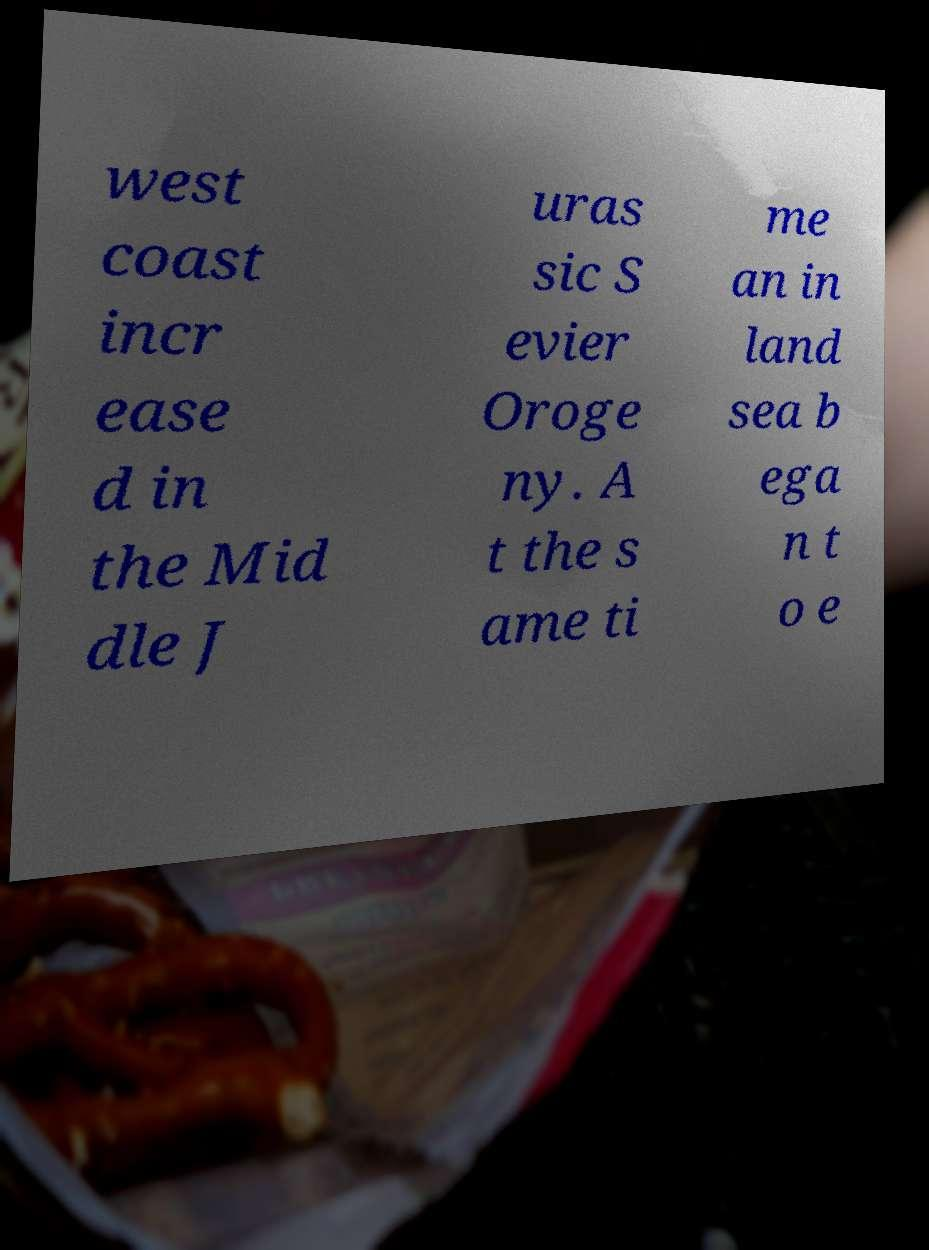Could you assist in decoding the text presented in this image and type it out clearly? west coast incr ease d in the Mid dle J uras sic S evier Oroge ny. A t the s ame ti me an in land sea b ega n t o e 